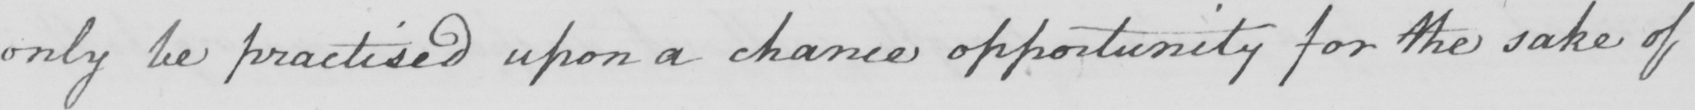Please transcribe the handwritten text in this image. only be practised upon a chance opportunity for the sake of 